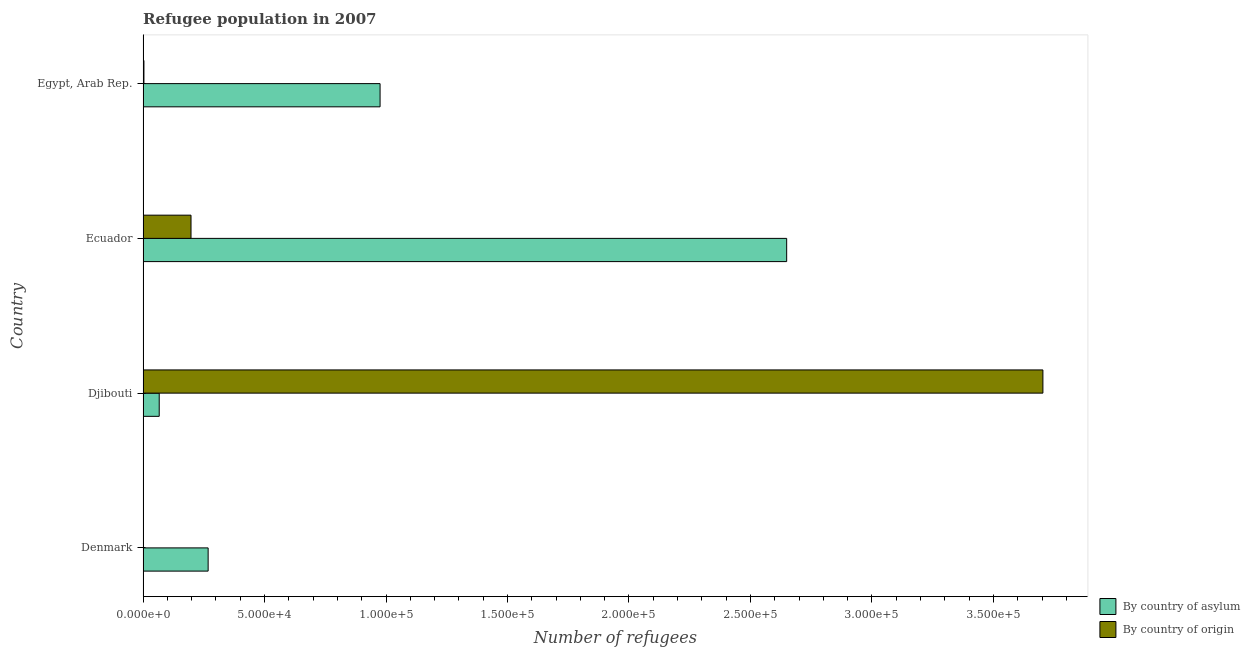How many groups of bars are there?
Provide a succinct answer. 4. Are the number of bars on each tick of the Y-axis equal?
Keep it short and to the point. Yes. How many bars are there on the 4th tick from the bottom?
Make the answer very short. 2. What is the label of the 4th group of bars from the top?
Your answer should be compact. Denmark. What is the number of refugees by country of origin in Egypt, Arab Rep.?
Make the answer very short. 361. Across all countries, what is the maximum number of refugees by country of origin?
Give a very brief answer. 3.70e+05. Across all countries, what is the minimum number of refugees by country of origin?
Keep it short and to the point. 96. In which country was the number of refugees by country of origin maximum?
Keep it short and to the point. Djibouti. What is the total number of refugees by country of origin in the graph?
Provide a short and direct response. 3.91e+05. What is the difference between the number of refugees by country of origin in Ecuador and that in Egypt, Arab Rep.?
Your response must be concise. 1.94e+04. What is the difference between the number of refugees by country of asylum in Djibouti and the number of refugees by country of origin in Denmark?
Provide a short and direct response. 6555. What is the average number of refugees by country of asylum per country?
Provide a short and direct response. 9.90e+04. What is the difference between the number of refugees by country of asylum and number of refugees by country of origin in Ecuador?
Offer a very short reply. 2.45e+05. In how many countries, is the number of refugees by country of origin greater than 270000 ?
Offer a terse response. 1. Is the number of refugees by country of origin in Denmark less than that in Djibouti?
Provide a short and direct response. Yes. What is the difference between the highest and the second highest number of refugees by country of origin?
Your answer should be compact. 3.51e+05. What is the difference between the highest and the lowest number of refugees by country of origin?
Your answer should be very brief. 3.70e+05. In how many countries, is the number of refugees by country of asylum greater than the average number of refugees by country of asylum taken over all countries?
Provide a succinct answer. 1. Is the sum of the number of refugees by country of origin in Denmark and Djibouti greater than the maximum number of refugees by country of asylum across all countries?
Ensure brevity in your answer.  Yes. What does the 2nd bar from the top in Ecuador represents?
Provide a short and direct response. By country of asylum. What does the 2nd bar from the bottom in Egypt, Arab Rep. represents?
Offer a very short reply. By country of origin. Are all the bars in the graph horizontal?
Ensure brevity in your answer.  Yes. What is the difference between two consecutive major ticks on the X-axis?
Provide a succinct answer. 5.00e+04. Where does the legend appear in the graph?
Ensure brevity in your answer.  Bottom right. How many legend labels are there?
Offer a terse response. 2. How are the legend labels stacked?
Offer a terse response. Vertical. What is the title of the graph?
Give a very brief answer. Refugee population in 2007. Does "Taxes" appear as one of the legend labels in the graph?
Make the answer very short. No. What is the label or title of the X-axis?
Provide a short and direct response. Number of refugees. What is the label or title of the Y-axis?
Keep it short and to the point. Country. What is the Number of refugees of By country of asylum in Denmark?
Ensure brevity in your answer.  2.68e+04. What is the Number of refugees in By country of origin in Denmark?
Ensure brevity in your answer.  96. What is the Number of refugees of By country of asylum in Djibouti?
Your response must be concise. 6651. What is the Number of refugees of By country of origin in Djibouti?
Your answer should be very brief. 3.70e+05. What is the Number of refugees in By country of asylum in Ecuador?
Offer a very short reply. 2.65e+05. What is the Number of refugees of By country of origin in Ecuador?
Give a very brief answer. 1.97e+04. What is the Number of refugees in By country of asylum in Egypt, Arab Rep.?
Keep it short and to the point. 9.76e+04. What is the Number of refugees in By country of origin in Egypt, Arab Rep.?
Offer a terse response. 361. Across all countries, what is the maximum Number of refugees of By country of asylum?
Your answer should be very brief. 2.65e+05. Across all countries, what is the maximum Number of refugees of By country of origin?
Provide a short and direct response. 3.70e+05. Across all countries, what is the minimum Number of refugees in By country of asylum?
Offer a very short reply. 6651. Across all countries, what is the minimum Number of refugees of By country of origin?
Provide a short and direct response. 96. What is the total Number of refugees in By country of asylum in the graph?
Offer a very short reply. 3.96e+05. What is the total Number of refugees in By country of origin in the graph?
Keep it short and to the point. 3.91e+05. What is the difference between the Number of refugees in By country of asylum in Denmark and that in Djibouti?
Your response must be concise. 2.01e+04. What is the difference between the Number of refugees of By country of origin in Denmark and that in Djibouti?
Offer a very short reply. -3.70e+05. What is the difference between the Number of refugees in By country of asylum in Denmark and that in Ecuador?
Ensure brevity in your answer.  -2.38e+05. What is the difference between the Number of refugees in By country of origin in Denmark and that in Ecuador?
Offer a very short reply. -1.96e+04. What is the difference between the Number of refugees in By country of asylum in Denmark and that in Egypt, Arab Rep.?
Make the answer very short. -7.08e+04. What is the difference between the Number of refugees of By country of origin in Denmark and that in Egypt, Arab Rep.?
Give a very brief answer. -265. What is the difference between the Number of refugees in By country of asylum in Djibouti and that in Ecuador?
Make the answer very short. -2.58e+05. What is the difference between the Number of refugees of By country of origin in Djibouti and that in Ecuador?
Your answer should be very brief. 3.51e+05. What is the difference between the Number of refugees in By country of asylum in Djibouti and that in Egypt, Arab Rep.?
Offer a terse response. -9.09e+04. What is the difference between the Number of refugees in By country of origin in Djibouti and that in Egypt, Arab Rep.?
Your response must be concise. 3.70e+05. What is the difference between the Number of refugees of By country of asylum in Ecuador and that in Egypt, Arab Rep.?
Provide a succinct answer. 1.67e+05. What is the difference between the Number of refugees of By country of origin in Ecuador and that in Egypt, Arab Rep.?
Make the answer very short. 1.94e+04. What is the difference between the Number of refugees in By country of asylum in Denmark and the Number of refugees in By country of origin in Djibouti?
Offer a very short reply. -3.44e+05. What is the difference between the Number of refugees of By country of asylum in Denmark and the Number of refugees of By country of origin in Ecuador?
Ensure brevity in your answer.  7053. What is the difference between the Number of refugees of By country of asylum in Denmark and the Number of refugees of By country of origin in Egypt, Arab Rep.?
Offer a very short reply. 2.64e+04. What is the difference between the Number of refugees of By country of asylum in Djibouti and the Number of refugees of By country of origin in Ecuador?
Offer a terse response. -1.31e+04. What is the difference between the Number of refugees in By country of asylum in Djibouti and the Number of refugees in By country of origin in Egypt, Arab Rep.?
Keep it short and to the point. 6290. What is the difference between the Number of refugees in By country of asylum in Ecuador and the Number of refugees in By country of origin in Egypt, Arab Rep.?
Provide a succinct answer. 2.65e+05. What is the average Number of refugees in By country of asylum per country?
Ensure brevity in your answer.  9.90e+04. What is the average Number of refugees in By country of origin per country?
Make the answer very short. 9.76e+04. What is the difference between the Number of refugees of By country of asylum and Number of refugees of By country of origin in Denmark?
Provide a succinct answer. 2.67e+04. What is the difference between the Number of refugees in By country of asylum and Number of refugees in By country of origin in Djibouti?
Provide a succinct answer. -3.64e+05. What is the difference between the Number of refugees in By country of asylum and Number of refugees in By country of origin in Ecuador?
Make the answer very short. 2.45e+05. What is the difference between the Number of refugees in By country of asylum and Number of refugees in By country of origin in Egypt, Arab Rep.?
Offer a terse response. 9.72e+04. What is the ratio of the Number of refugees of By country of asylum in Denmark to that in Djibouti?
Your response must be concise. 4.03. What is the ratio of the Number of refugees of By country of asylum in Denmark to that in Ecuador?
Keep it short and to the point. 0.1. What is the ratio of the Number of refugees of By country of origin in Denmark to that in Ecuador?
Offer a terse response. 0. What is the ratio of the Number of refugees in By country of asylum in Denmark to that in Egypt, Arab Rep.?
Ensure brevity in your answer.  0.27. What is the ratio of the Number of refugees in By country of origin in Denmark to that in Egypt, Arab Rep.?
Offer a terse response. 0.27. What is the ratio of the Number of refugees in By country of asylum in Djibouti to that in Ecuador?
Your answer should be very brief. 0.03. What is the ratio of the Number of refugees in By country of origin in Djibouti to that in Ecuador?
Offer a very short reply. 18.77. What is the ratio of the Number of refugees in By country of asylum in Djibouti to that in Egypt, Arab Rep.?
Keep it short and to the point. 0.07. What is the ratio of the Number of refugees of By country of origin in Djibouti to that in Egypt, Arab Rep.?
Give a very brief answer. 1025.97. What is the ratio of the Number of refugees of By country of asylum in Ecuador to that in Egypt, Arab Rep.?
Provide a short and direct response. 2.72. What is the ratio of the Number of refugees of By country of origin in Ecuador to that in Egypt, Arab Rep.?
Keep it short and to the point. 54.67. What is the difference between the highest and the second highest Number of refugees of By country of asylum?
Keep it short and to the point. 1.67e+05. What is the difference between the highest and the second highest Number of refugees in By country of origin?
Your answer should be compact. 3.51e+05. What is the difference between the highest and the lowest Number of refugees of By country of asylum?
Your answer should be compact. 2.58e+05. What is the difference between the highest and the lowest Number of refugees of By country of origin?
Make the answer very short. 3.70e+05. 